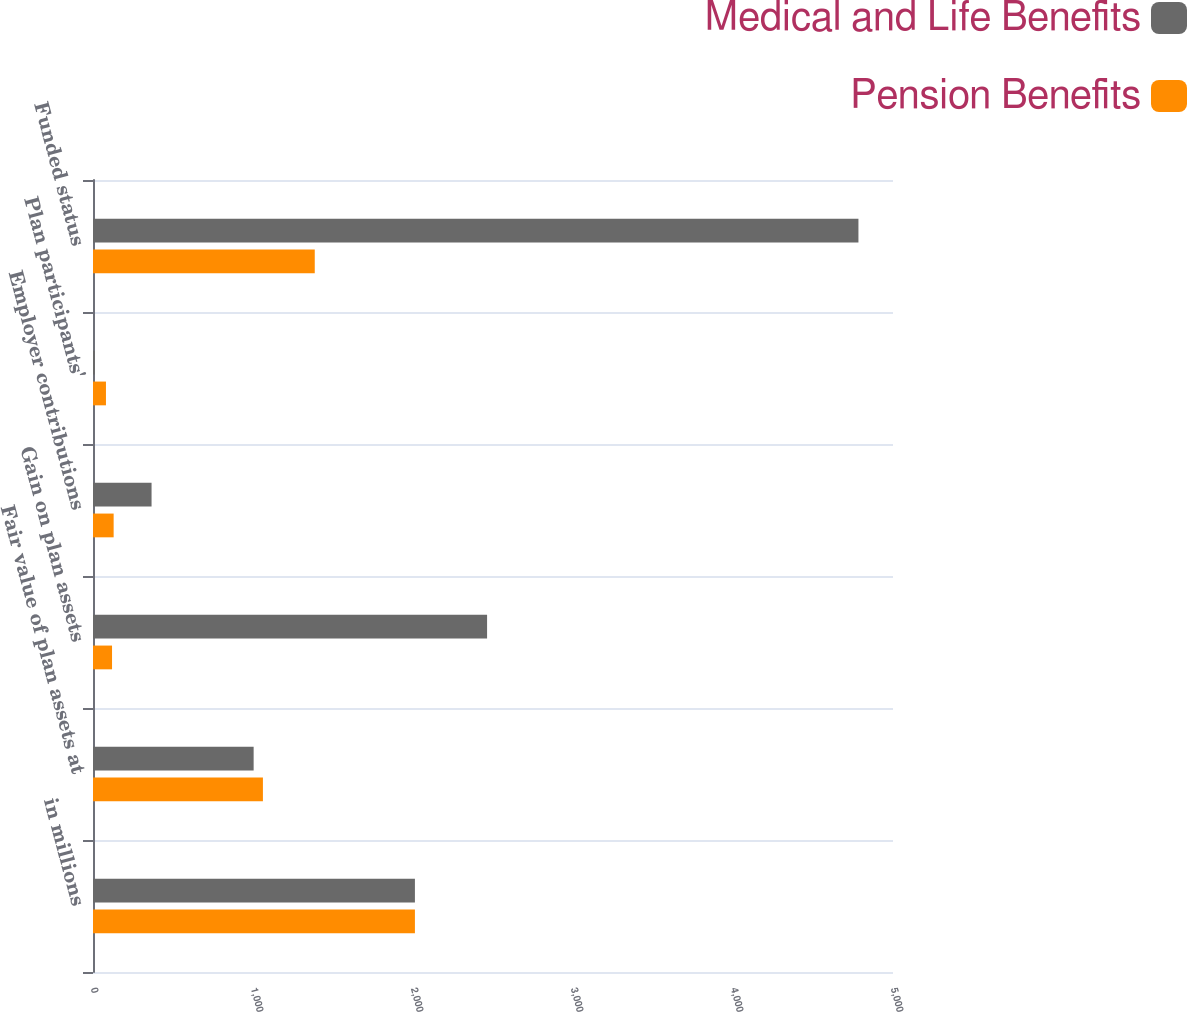Convert chart to OTSL. <chart><loc_0><loc_0><loc_500><loc_500><stacked_bar_chart><ecel><fcel>in millions<fcel>Fair value of plan assets at<fcel>Gain on plan assets<fcel>Employer contributions<fcel>Plan participants'<fcel>Funded status<nl><fcel>Medical and Life Benefits<fcel>2012<fcel>1004<fcel>2463<fcel>366<fcel>12<fcel>4784<nl><fcel>Pension Benefits<fcel>2012<fcel>1062<fcel>119<fcel>129<fcel>81<fcel>1386<nl></chart> 